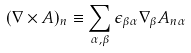Convert formula to latex. <formula><loc_0><loc_0><loc_500><loc_500>( \nabla \times A ) _ { n } \equiv \sum _ { \alpha , \beta } \epsilon _ { \beta \alpha } \nabla _ { \beta } A _ { { n } \alpha }</formula> 